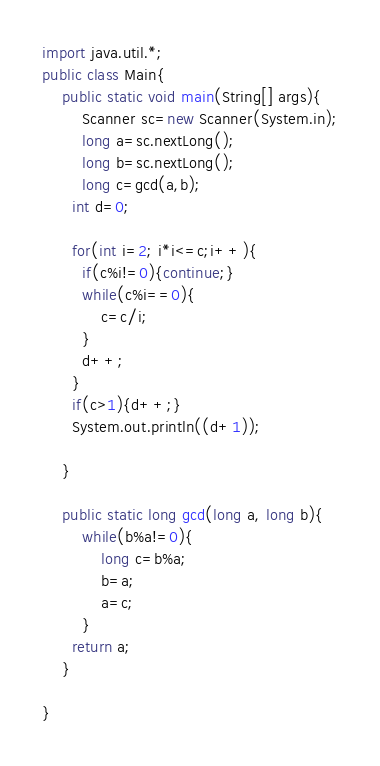<code> <loc_0><loc_0><loc_500><loc_500><_Java_>import java.util.*;
public class Main{
	public static void main(String[] args){
    	Scanner sc=new Scanner(System.in);
        long a=sc.nextLong();
      	long b=sc.nextLong();
    	long c=gcd(a,b);
      int d=0;
      
      for(int i=2; i*i<=c;i++){
        if(c%i!=0){continue;}
      	while(c%i==0){
        	c=c/i;
        }
        d++;
      }
      if(c>1){d++;}
      System.out.println((d+1));
        
    }
  	
  	public static long gcd(long a, long b){
    	while(b%a!=0){
        	long c=b%a;
          	b=a;
          	a=c;
        }
      return a;
    }
  
}</code> 